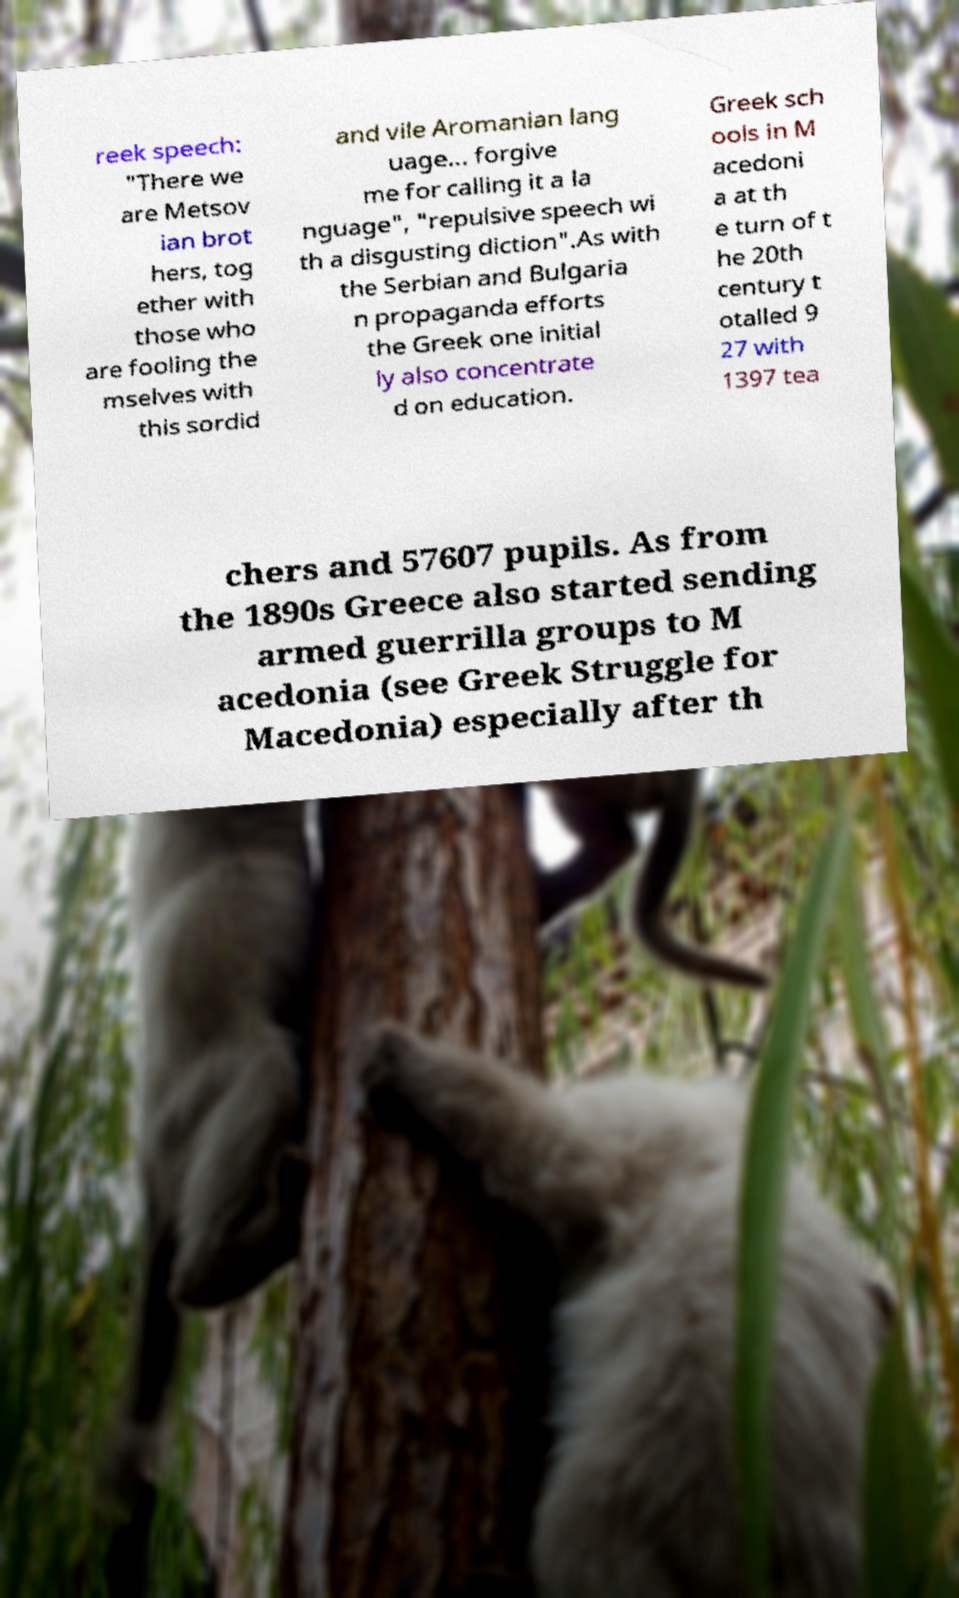I need the written content from this picture converted into text. Can you do that? reek speech: "There we are Metsov ian brot hers, tog ether with those who are fooling the mselves with this sordid and vile Aromanian lang uage... forgive me for calling it a la nguage", "repulsive speech wi th a disgusting diction".As with the Serbian and Bulgaria n propaganda efforts the Greek one initial ly also concentrate d on education. Greek sch ools in M acedoni a at th e turn of t he 20th century t otalled 9 27 with 1397 tea chers and 57607 pupils. As from the 1890s Greece also started sending armed guerrilla groups to M acedonia (see Greek Struggle for Macedonia) especially after th 